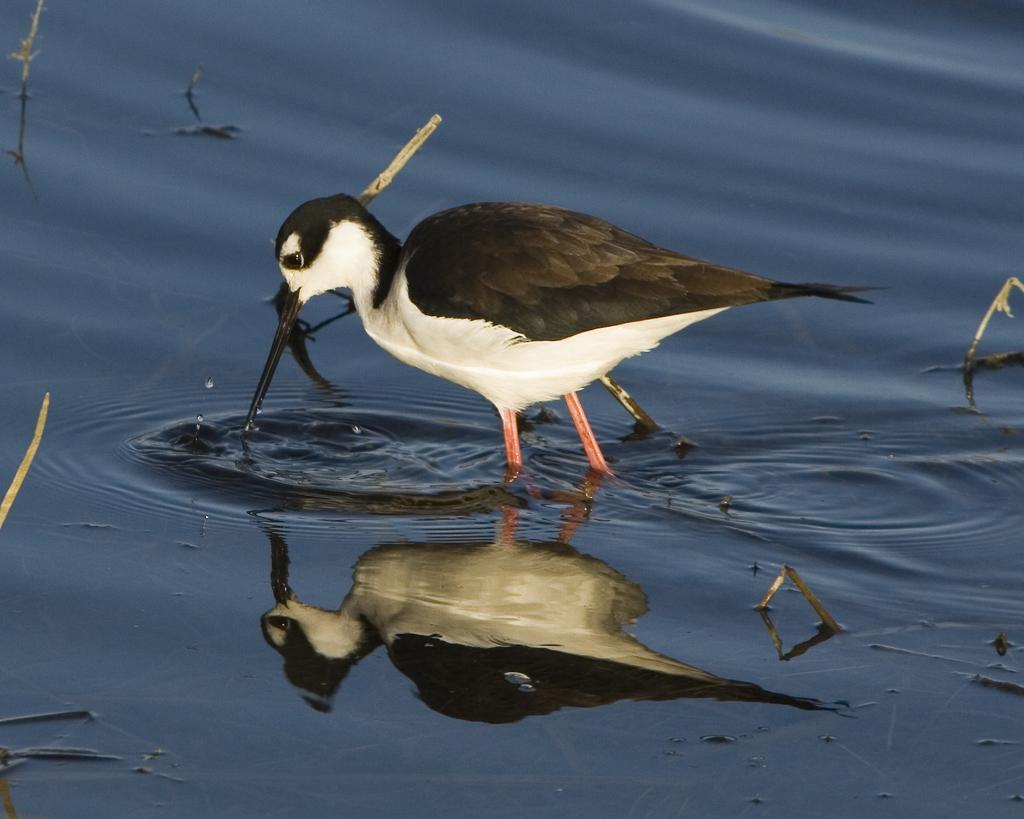What is the bird doing in the image? The bird is standing in the water. What else can be seen in the image besides the bird? There are objects visible in the image. What type of advice is the bird giving to the toys in the image? There are no toys present in the image, and the bird is not giving any advice. 